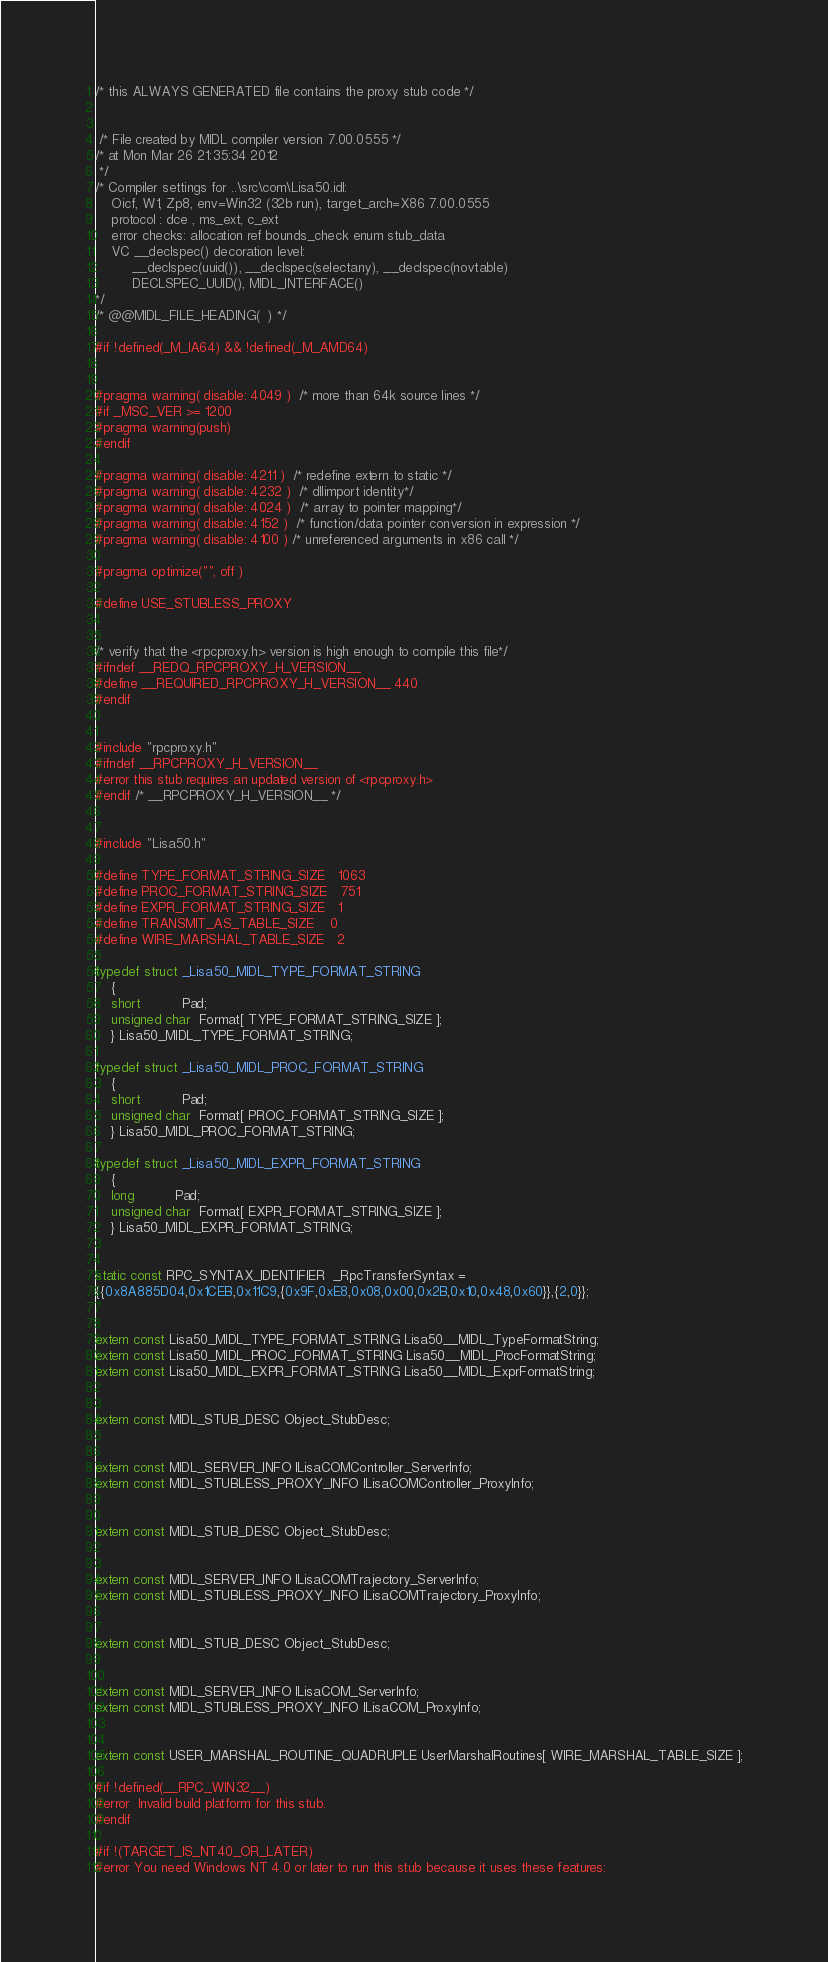<code> <loc_0><loc_0><loc_500><loc_500><_C_>

/* this ALWAYS GENERATED file contains the proxy stub code */


 /* File created by MIDL compiler version 7.00.0555 */
/* at Mon Mar 26 21:35:34 2012
 */
/* Compiler settings for ..\src\com\Lisa50.idl:
    Oicf, W1, Zp8, env=Win32 (32b run), target_arch=X86 7.00.0555 
    protocol : dce , ms_ext, c_ext
    error checks: allocation ref bounds_check enum stub_data 
    VC __declspec() decoration level: 
         __declspec(uuid()), __declspec(selectany), __declspec(novtable)
         DECLSPEC_UUID(), MIDL_INTERFACE()
*/
/* @@MIDL_FILE_HEADING(  ) */

#if !defined(_M_IA64) && !defined(_M_AMD64)


#pragma warning( disable: 4049 )  /* more than 64k source lines */
#if _MSC_VER >= 1200
#pragma warning(push)
#endif

#pragma warning( disable: 4211 )  /* redefine extern to static */
#pragma warning( disable: 4232 )  /* dllimport identity*/
#pragma warning( disable: 4024 )  /* array to pointer mapping*/
#pragma warning( disable: 4152 )  /* function/data pointer conversion in expression */
#pragma warning( disable: 4100 ) /* unreferenced arguments in x86 call */

#pragma optimize("", off ) 

#define USE_STUBLESS_PROXY


/* verify that the <rpcproxy.h> version is high enough to compile this file*/
#ifndef __REDQ_RPCPROXY_H_VERSION__
#define __REQUIRED_RPCPROXY_H_VERSION__ 440
#endif


#include "rpcproxy.h"
#ifndef __RPCPROXY_H_VERSION__
#error this stub requires an updated version of <rpcproxy.h>
#endif /* __RPCPROXY_H_VERSION__ */


#include "Lisa50.h"

#define TYPE_FORMAT_STRING_SIZE   1063                              
#define PROC_FORMAT_STRING_SIZE   751                               
#define EXPR_FORMAT_STRING_SIZE   1                                 
#define TRANSMIT_AS_TABLE_SIZE    0            
#define WIRE_MARSHAL_TABLE_SIZE   2            

typedef struct _Lisa50_MIDL_TYPE_FORMAT_STRING
    {
    short          Pad;
    unsigned char  Format[ TYPE_FORMAT_STRING_SIZE ];
    } Lisa50_MIDL_TYPE_FORMAT_STRING;

typedef struct _Lisa50_MIDL_PROC_FORMAT_STRING
    {
    short          Pad;
    unsigned char  Format[ PROC_FORMAT_STRING_SIZE ];
    } Lisa50_MIDL_PROC_FORMAT_STRING;

typedef struct _Lisa50_MIDL_EXPR_FORMAT_STRING
    {
    long          Pad;
    unsigned char  Format[ EXPR_FORMAT_STRING_SIZE ];
    } Lisa50_MIDL_EXPR_FORMAT_STRING;


static const RPC_SYNTAX_IDENTIFIER  _RpcTransferSyntax = 
{{0x8A885D04,0x1CEB,0x11C9,{0x9F,0xE8,0x08,0x00,0x2B,0x10,0x48,0x60}},{2,0}};


extern const Lisa50_MIDL_TYPE_FORMAT_STRING Lisa50__MIDL_TypeFormatString;
extern const Lisa50_MIDL_PROC_FORMAT_STRING Lisa50__MIDL_ProcFormatString;
extern const Lisa50_MIDL_EXPR_FORMAT_STRING Lisa50__MIDL_ExprFormatString;


extern const MIDL_STUB_DESC Object_StubDesc;


extern const MIDL_SERVER_INFO ILisaCOMController_ServerInfo;
extern const MIDL_STUBLESS_PROXY_INFO ILisaCOMController_ProxyInfo;


extern const MIDL_STUB_DESC Object_StubDesc;


extern const MIDL_SERVER_INFO ILisaCOMTrajectory_ServerInfo;
extern const MIDL_STUBLESS_PROXY_INFO ILisaCOMTrajectory_ProxyInfo;


extern const MIDL_STUB_DESC Object_StubDesc;


extern const MIDL_SERVER_INFO ILisaCOM_ServerInfo;
extern const MIDL_STUBLESS_PROXY_INFO ILisaCOM_ProxyInfo;


extern const USER_MARSHAL_ROUTINE_QUADRUPLE UserMarshalRoutines[ WIRE_MARSHAL_TABLE_SIZE ];

#if !defined(__RPC_WIN32__)
#error  Invalid build platform for this stub.
#endif

#if !(TARGET_IS_NT40_OR_LATER)
#error You need Windows NT 4.0 or later to run this stub because it uses these features:</code> 